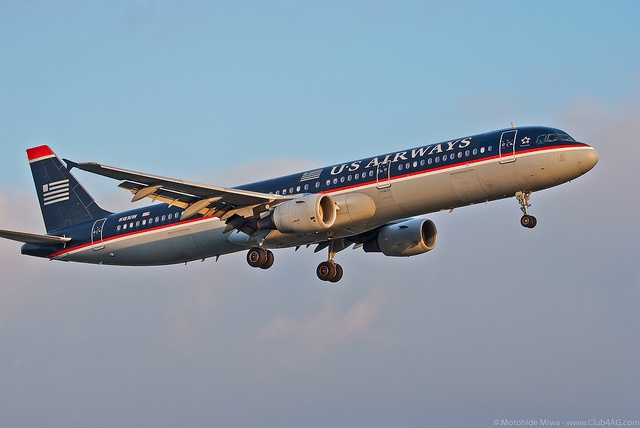Describe the objects in this image and their specific colors. I can see a airplane in lightblue, black, navy, tan, and darkgray tones in this image. 